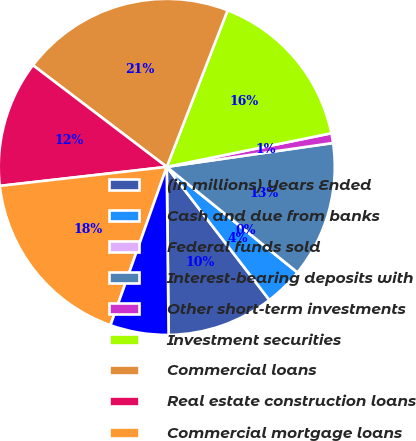<chart> <loc_0><loc_0><loc_500><loc_500><pie_chart><fcel>(in millions) Years Ended<fcel>Cash and due from banks<fcel>Federal funds sold<fcel>Interest-bearing deposits with<fcel>Other short-term investments<fcel>Investment securities<fcel>Commercial loans<fcel>Real estate construction loans<fcel>Commercial mortgage loans<fcel>Lease financing<nl><fcel>10.28%<fcel>3.74%<fcel>0.0%<fcel>13.08%<fcel>0.94%<fcel>15.89%<fcel>20.56%<fcel>12.15%<fcel>17.76%<fcel>5.61%<nl></chart> 